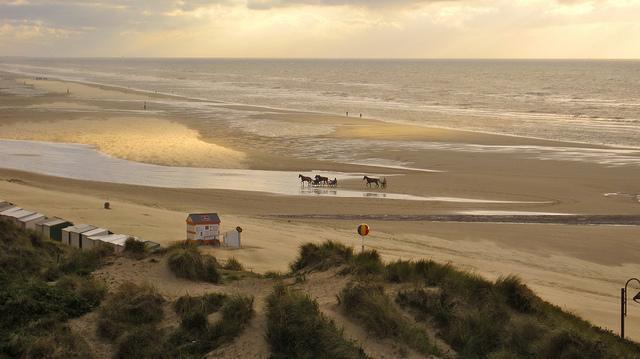What are the horses doing?
Choose the right answer and clarify with the format: 'Answer: answer
Rationale: rationale.'
Options: Feeding, resting, pulling surfers, pulling sleds. Answer: pulling sleds.
Rationale: The horses are on the beach. the people near them appear to be in wetsuits. 